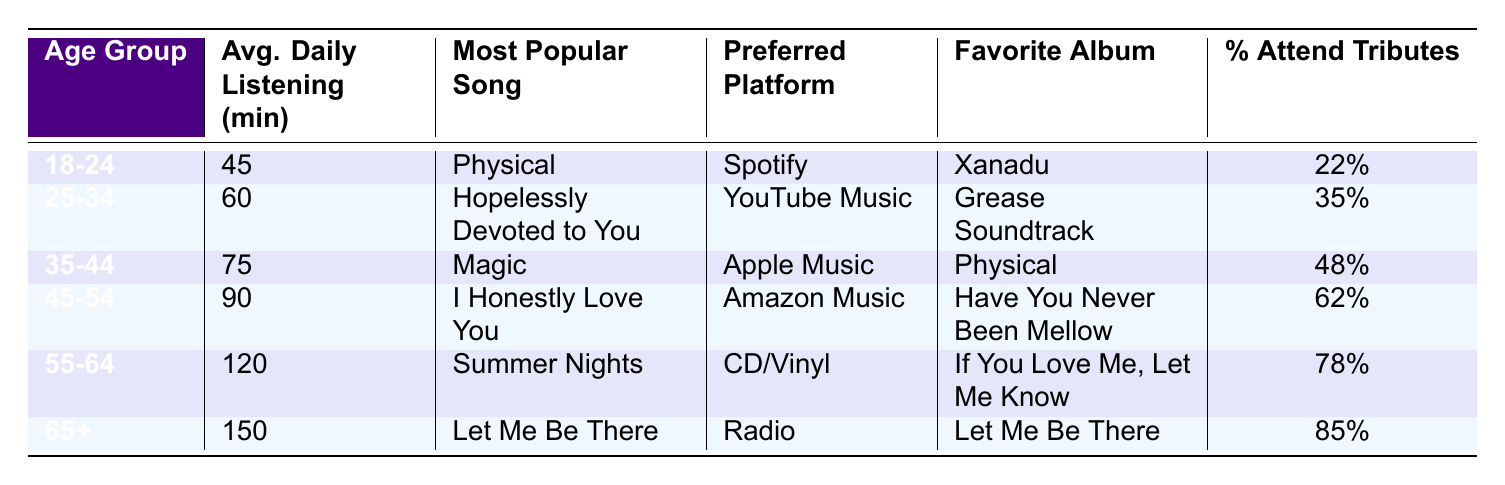What is the average daily listening time for the 45-54 age group? The table shows that the average daily listening time for the 45-54 age group is 90 minutes.
Answer: 90 minutes Which age group prefers Spotify as their listening platform? According to the table, the 18-24 age group prefers Spotify as their listening platform.
Answer: 18-24 What is the most popular song among fans aged 55-64? The table indicates that the most popular song among fans aged 55-64 is "Summer Nights."
Answer: Summer Nights What percentage of 25-34 year-olds attend ONJ tribute concerts? The table reveals that 35% of the 25-34 age group attend ONJ tribute concerts.
Answer: 35% Which age group has the highest average daily listening time? Comparing the average daily listening times, the 65+ age group has the highest time at 150 minutes.
Answer: 65+ If we take the average daily listening time of the 35-44 and 45-54 age groups, what is the result? The average daily listening time for the 35-44 age group is 75 minutes and for the 45-54 age group is 90 minutes. The average is (75 + 90) / 2 = 82.5 minutes.
Answer: 82.5 minutes Is "Magic" the most popular song for the 25-34 age group? The table shows that "Magic" is the most popular song for the 35-44 age group, while "Hopelessly Devoted to You" is the most popular song for the 25-34 age group, so the statement is false.
Answer: No Which age group has the least percentage of attendees at ONJ tribute concerts? The table lists 22% for the 18-24 age group and 85% for the 65+ age group. Thus, the 18-24 age group has the least percentage of attendees.
Answer: 18-24 How many more minutes do fans aged 65+ listen to Olivia Newton-John's music daily compared to those aged 18-24? Fans aged 65+ listen for 150 minutes, while those aged 18-24 listen for 45 minutes. The difference is 150 - 45 = 105 minutes.
Answer: 105 minutes Is it true that fans aged 55-64 listen for 120 minutes daily on average? The table confirms that the average daily listening time for the 55-64 age group is indeed 120 minutes, so the statement is true.
Answer: Yes 